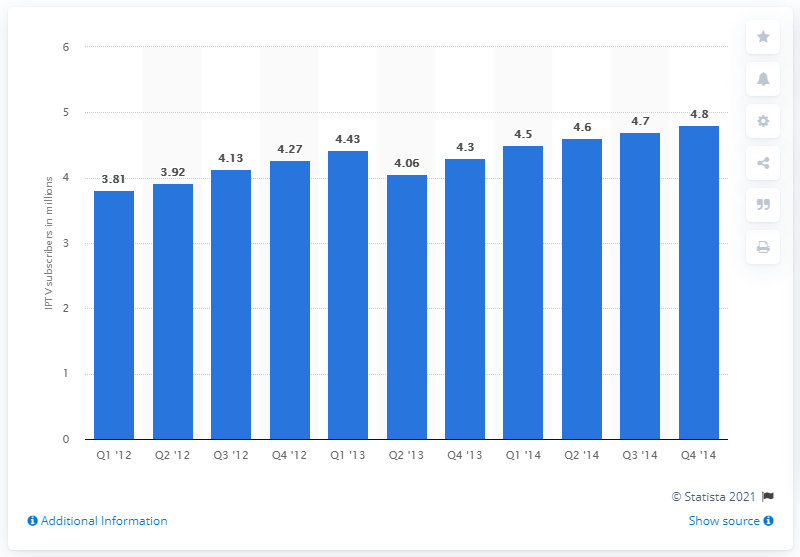Give some essential details in this illustration. In the fourth quarter of 2013, there were 4.3 million IPTV subscribers in Japan. 